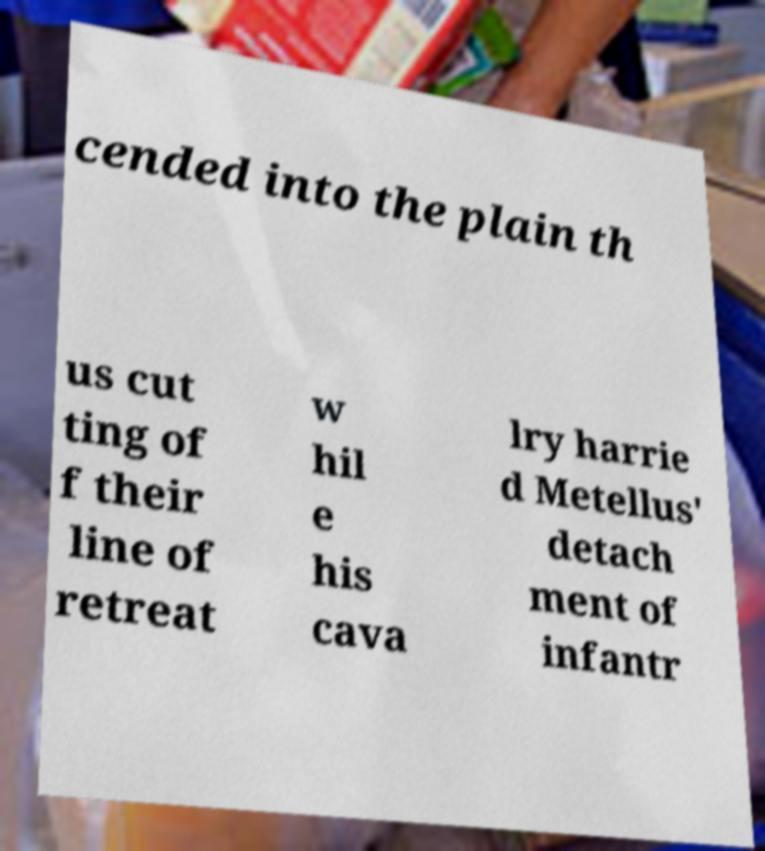What messages or text are displayed in this image? I need them in a readable, typed format. cended into the plain th us cut ting of f their line of retreat w hil e his cava lry harrie d Metellus' detach ment of infantr 